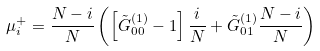Convert formula to latex. <formula><loc_0><loc_0><loc_500><loc_500>\mu ^ { + } _ { i } = \frac { N - i } { N } \left ( \left [ \tilde { G } ^ { ( 1 ) } _ { 0 0 } - 1 \right ] \frac { i } { N } + \tilde { G } ^ { ( 1 ) } _ { 0 1 } \frac { N - i } { N } \right )</formula> 